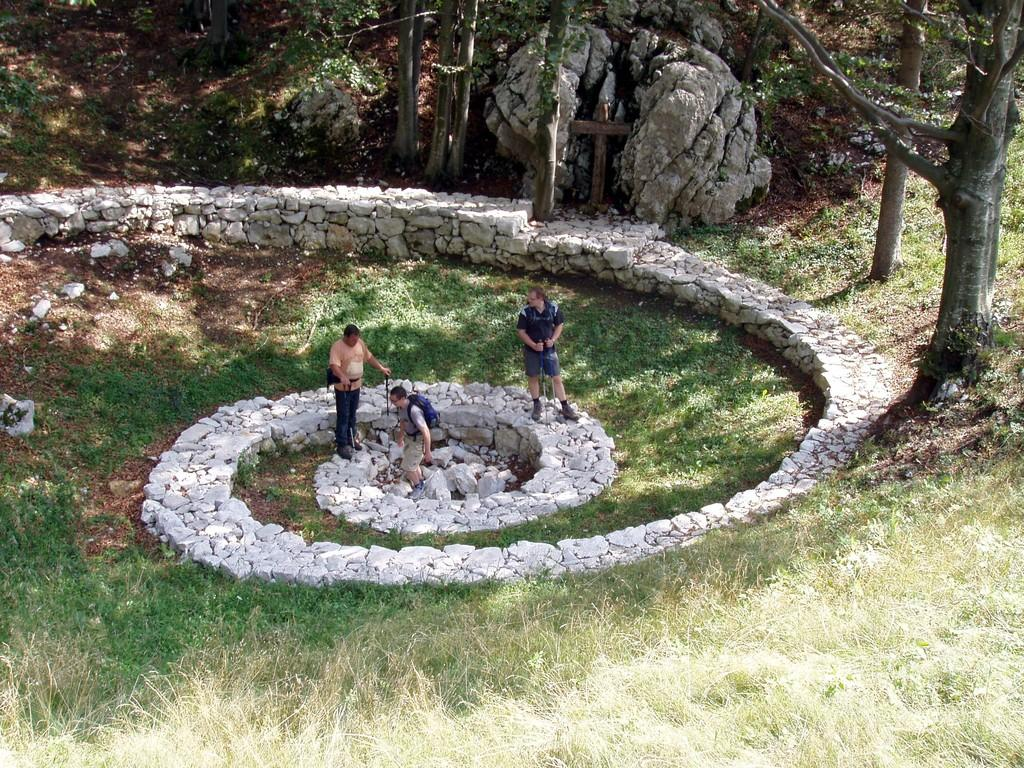What type of vegetation can be seen in the image? There is grass and trees in the image. What else is present in the image besides vegetation? Shadows and people are visible in the image. What type of berry is growing on the alley in the image? There is no alley or berry present in the image. What is the weather like in the image? The provided facts do not mention the weather, so it cannot be determined from the image. 